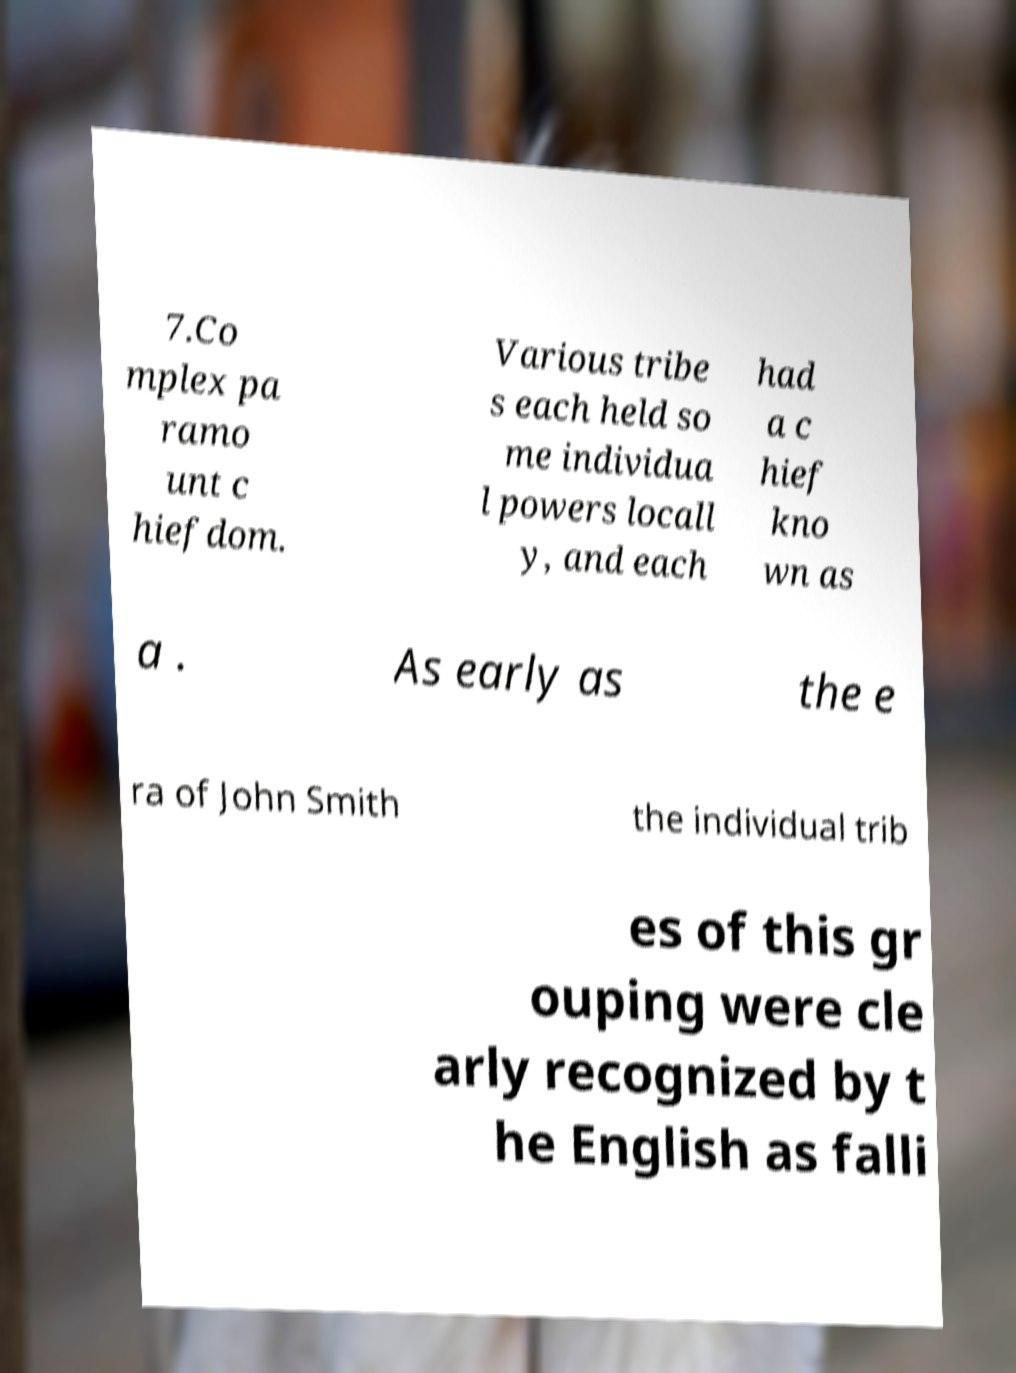For documentation purposes, I need the text within this image transcribed. Could you provide that? 7.Co mplex pa ramo unt c hiefdom. Various tribe s each held so me individua l powers locall y, and each had a c hief kno wn as a . As early as the e ra of John Smith the individual trib es of this gr ouping were cle arly recognized by t he English as falli 